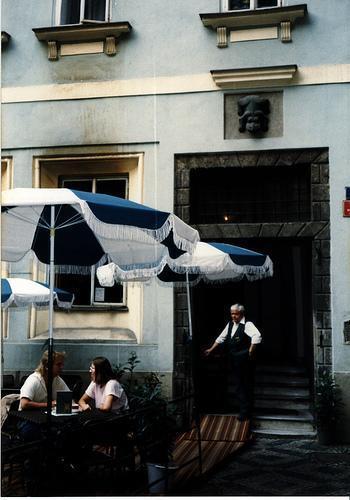How many women are shown?
Give a very brief answer. 1. How many people are shown?
Give a very brief answer. 3. 